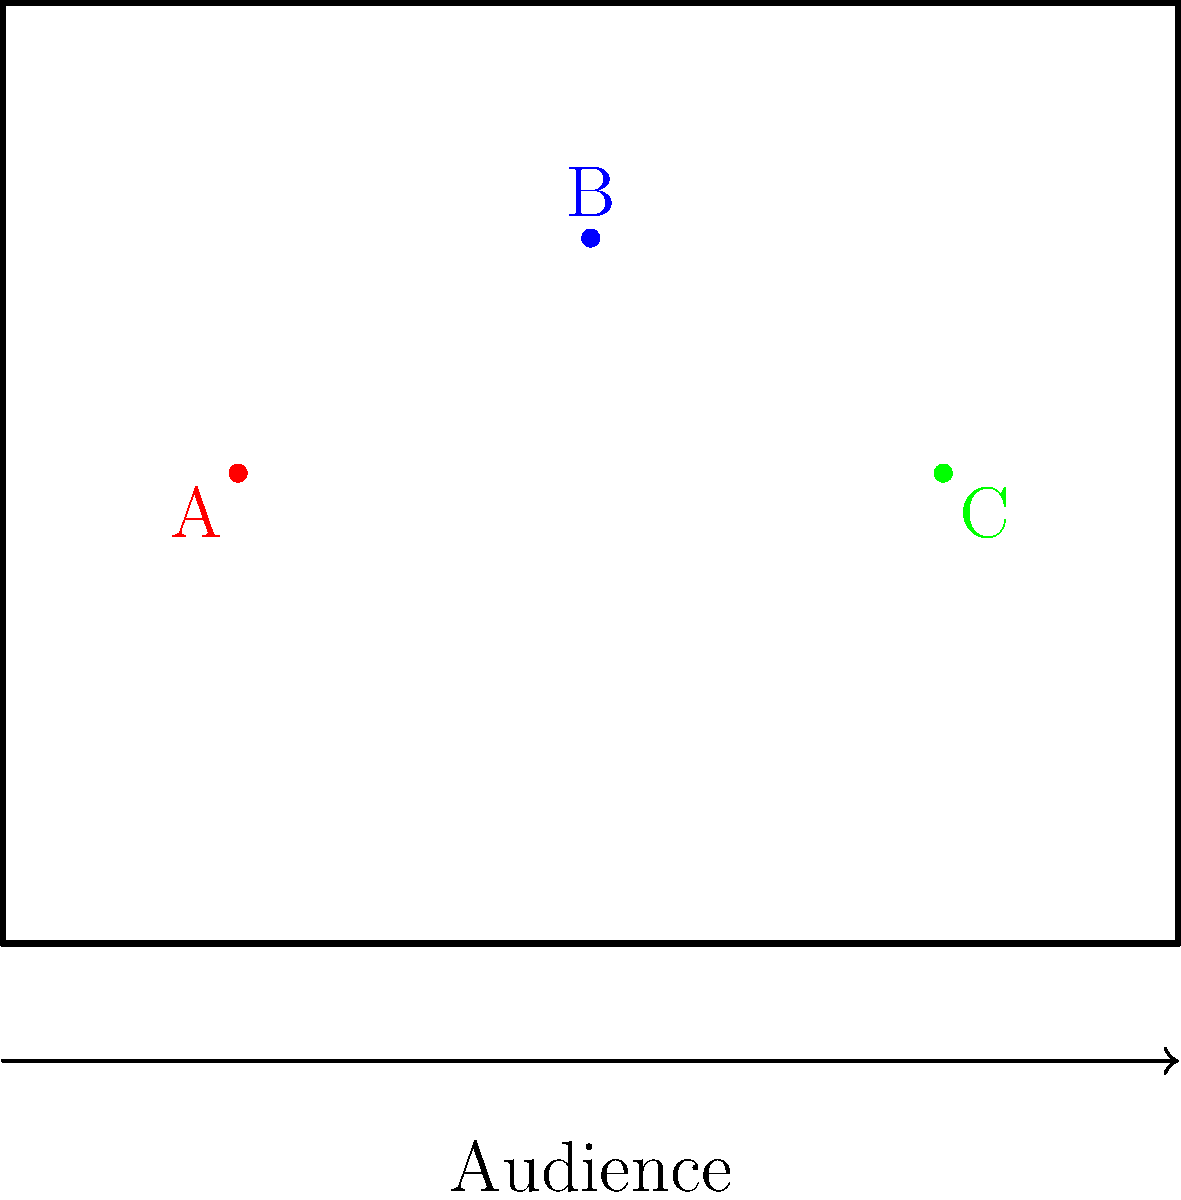In the stage diagram above, three actors (A, B, and C) are positioned for a dramatic confrontation scene. Considering the principles of stage composition and the need to maintain sight lines for the audience, which arrangement of the actors would create the most dynamic and visually engaging tableau? To determine the optimal staging position for the actors, we need to consider several factors:

1. Triangular Composition: The current arrangement forms a triangle, which is a strong and dynamic shape in stage composition. This creates visual interest and depth.

2. Depth: Actor B is positioned upstage (further from the audience), while A and C are downstage. This creates depth and allows for interesting blocking possibilities.

3. Sight Lines: All actors are visible to the audience, with no one completely blocking another.

4. Power Dynamics: The central, upstage position of B suggests a position of power or focus, with A and C potentially in conflict or reacting to B.

5. Movement Potential: This arrangement allows for dynamic movement possibilities, such as A and C moving towards each other or B coming downstage between them.

6. Rule of Thirds: The actors are roughly positioned along the thirds of the stage, both horizontally and vertically, which is pleasing to the eye.

7. Asymmetry: The slight asymmetry in the positioning (A and C are not exactly mirrored) adds visual interest and avoids a static feel.

Given these considerations, the current arrangement is indeed optimal for creating a dynamic and visually engaging tableau. It allows for clear sight lines, interesting power dynamics, and potential for movement while adhering to principles of strong stage composition.
Answer: The current arrangement (A downstage left, B upstage center, C downstage right) is optimal. 